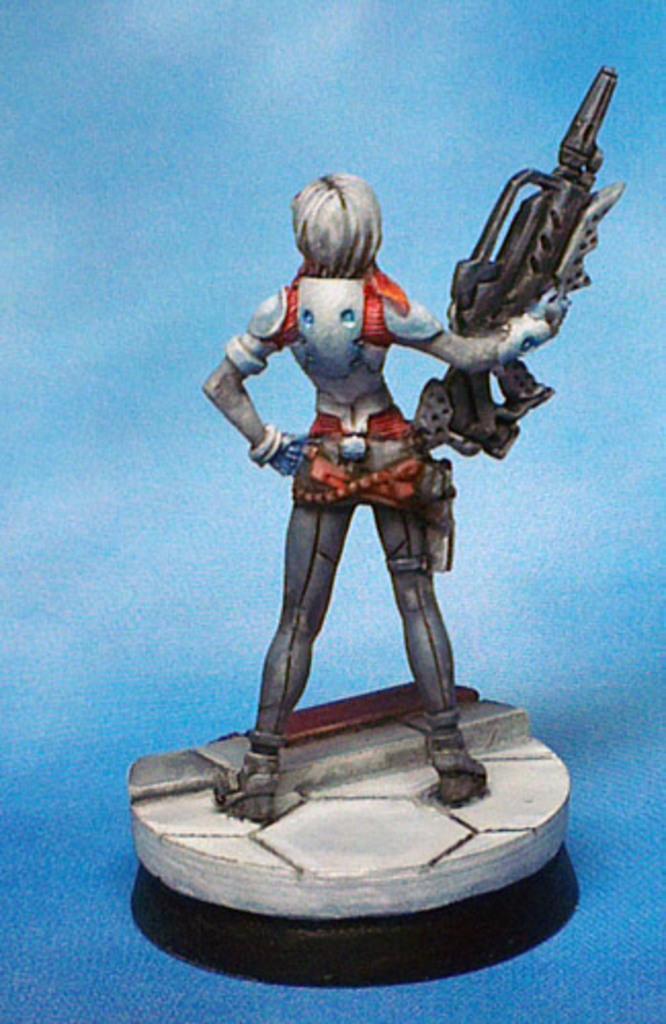Can you describe this image briefly? This is an animated image with a person standing and holding a gun. 